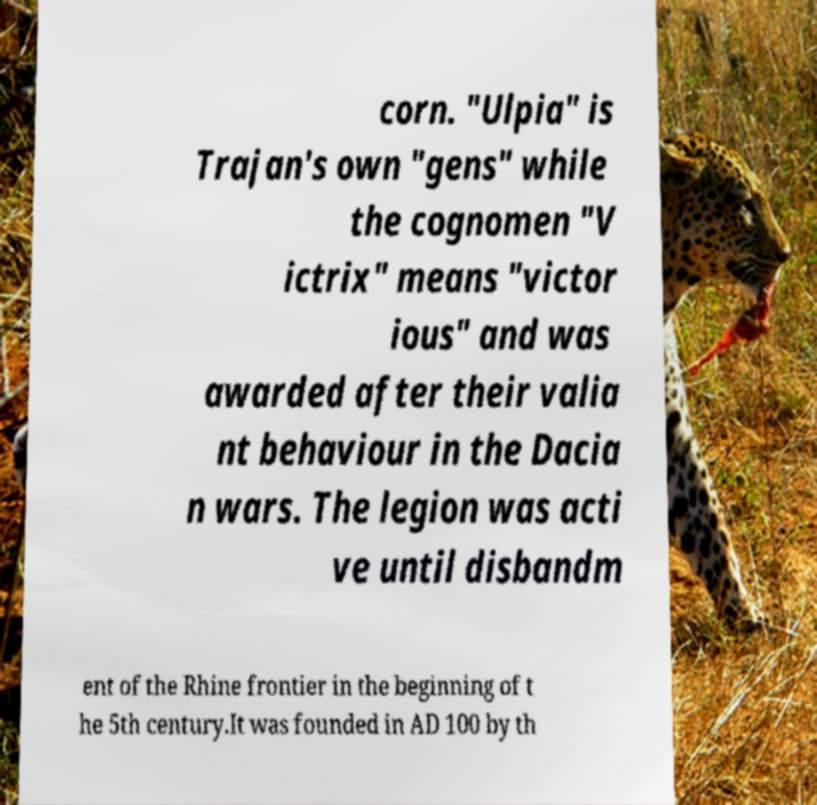I need the written content from this picture converted into text. Can you do that? corn. "Ulpia" is Trajan's own "gens" while the cognomen "V ictrix" means "victor ious" and was awarded after their valia nt behaviour in the Dacia n wars. The legion was acti ve until disbandm ent of the Rhine frontier in the beginning of t he 5th century.It was founded in AD 100 by th 